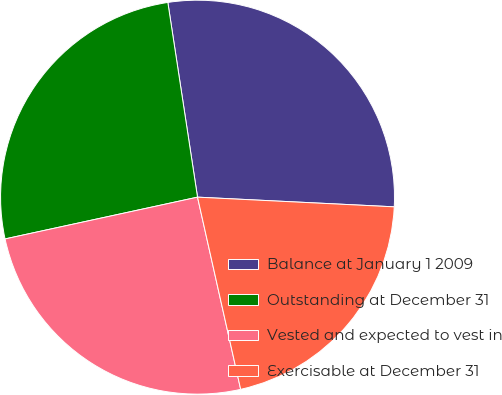Convert chart to OTSL. <chart><loc_0><loc_0><loc_500><loc_500><pie_chart><fcel>Balance at January 1 2009<fcel>Outstanding at December 31<fcel>Vested and expected to vest in<fcel>Exercisable at December 31<nl><fcel>28.19%<fcel>25.99%<fcel>25.11%<fcel>20.7%<nl></chart> 